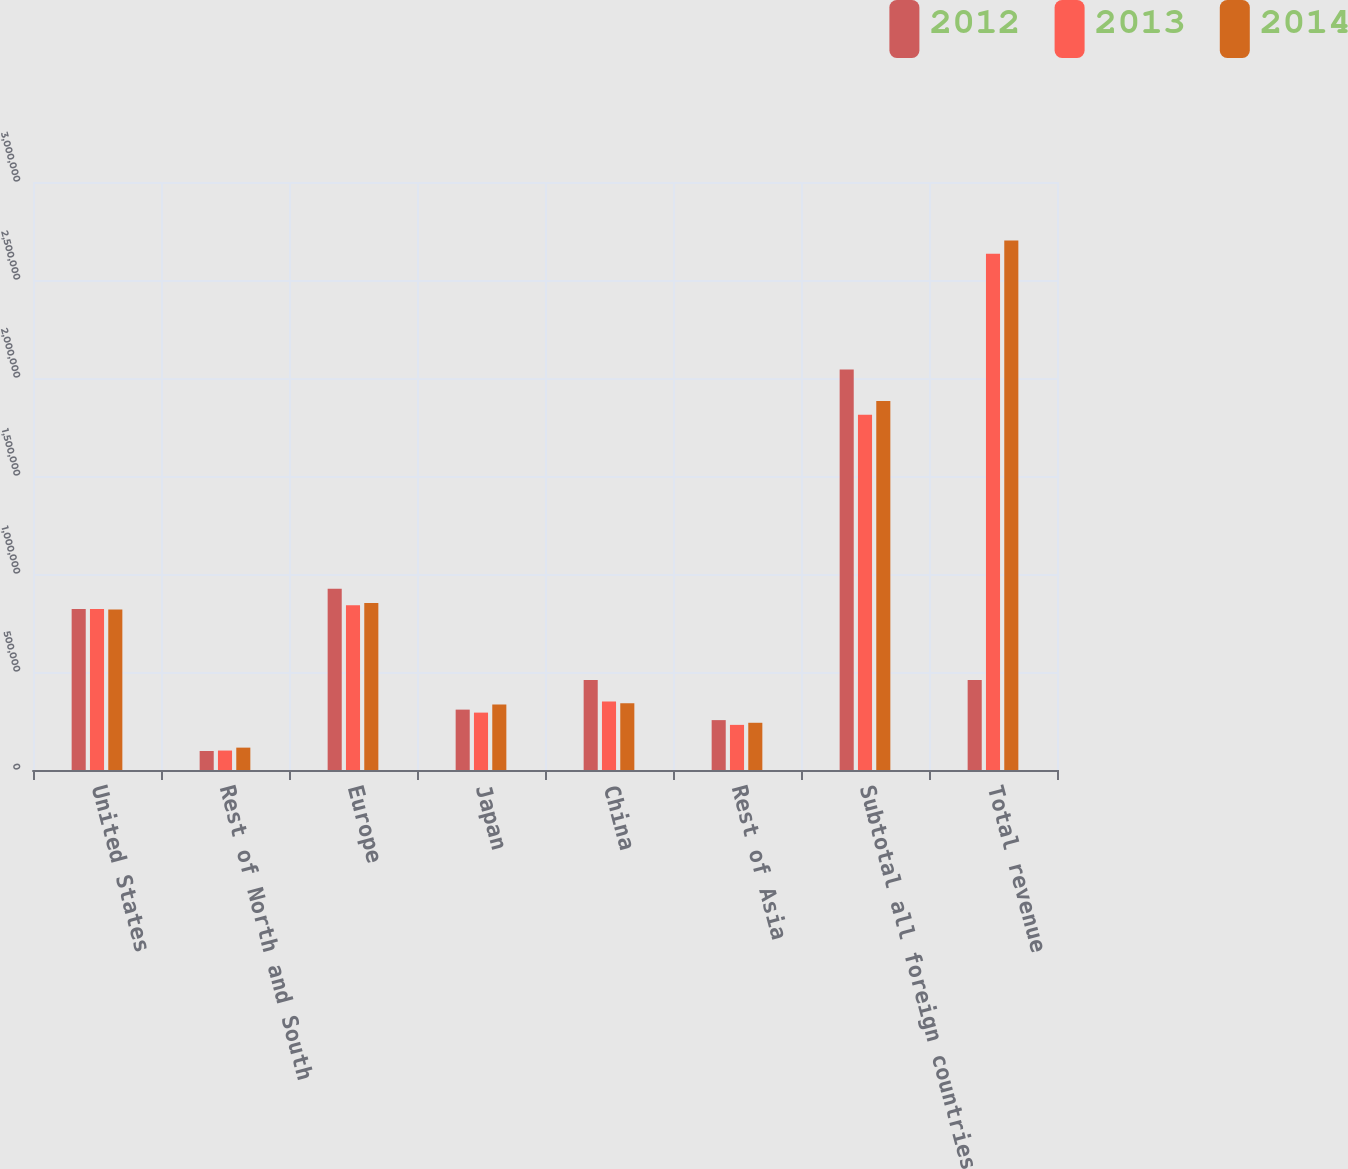Convert chart to OTSL. <chart><loc_0><loc_0><loc_500><loc_500><stacked_bar_chart><ecel><fcel>United States<fcel>Rest of North and South<fcel>Europe<fcel>Japan<fcel>China<fcel>Rest of Asia<fcel>Subtotal all foreign countries<fcel>Total revenue<nl><fcel>2012<fcel>821554<fcel>96957<fcel>924477<fcel>308054<fcel>459260<fcel>254471<fcel>2.04322e+06<fcel>459260<nl><fcel>2013<fcel>821269<fcel>99215<fcel>840585<fcel>292804<fcel>349575<fcel>230241<fcel>1.81242e+06<fcel>2.63369e+06<nl><fcel>2014<fcel>818653<fcel>114133<fcel>852668<fcel>333558<fcel>341196<fcel>240934<fcel>1.88249e+06<fcel>2.70114e+06<nl></chart> 